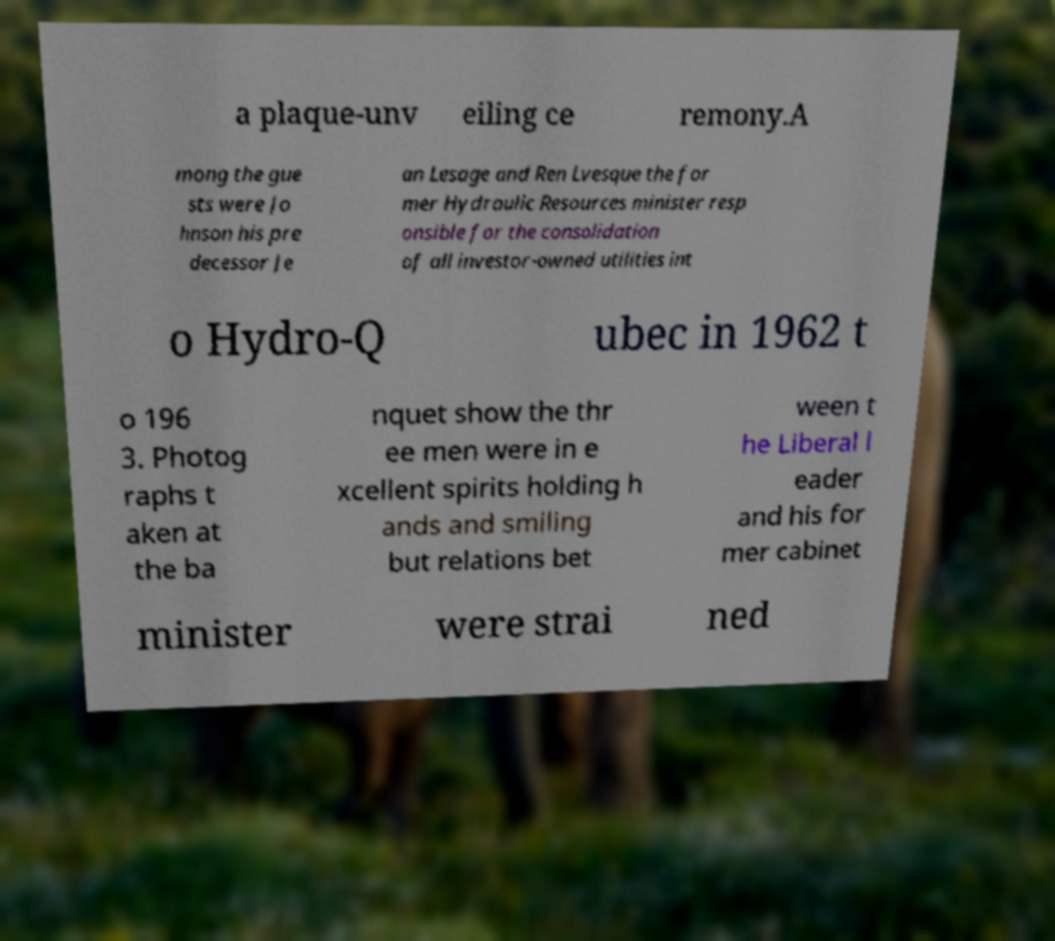Please read and relay the text visible in this image. What does it say? a plaque-unv eiling ce remony.A mong the gue sts were Jo hnson his pre decessor Je an Lesage and Ren Lvesque the for mer Hydraulic Resources minister resp onsible for the consolidation of all investor-owned utilities int o Hydro-Q ubec in 1962 t o 196 3. Photog raphs t aken at the ba nquet show the thr ee men were in e xcellent spirits holding h ands and smiling but relations bet ween t he Liberal l eader and his for mer cabinet minister were strai ned 